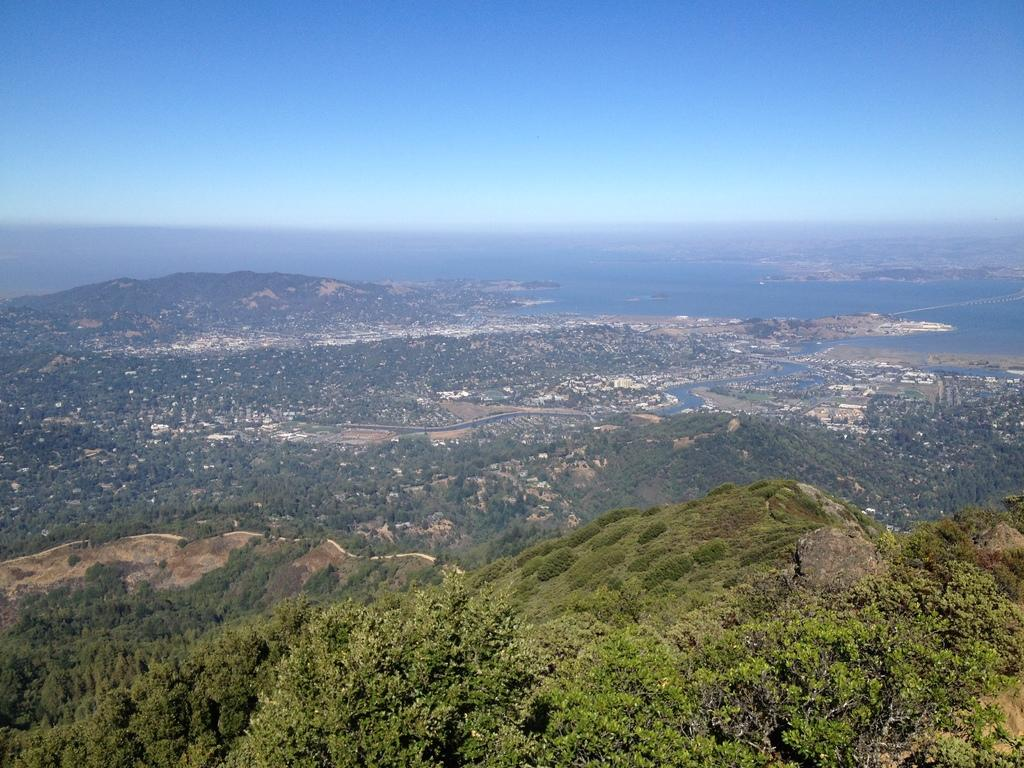What type of landscape is visible in the front of the image? There are hills in the front of the image. What can be seen on the hills in the image? The hills are covered with plants and trees. What body of water is visible in the back of the image? In the back of the image, there is an ocean. How many nails are used to hold the boys together in the image? There are no boys or nails present in the image. 